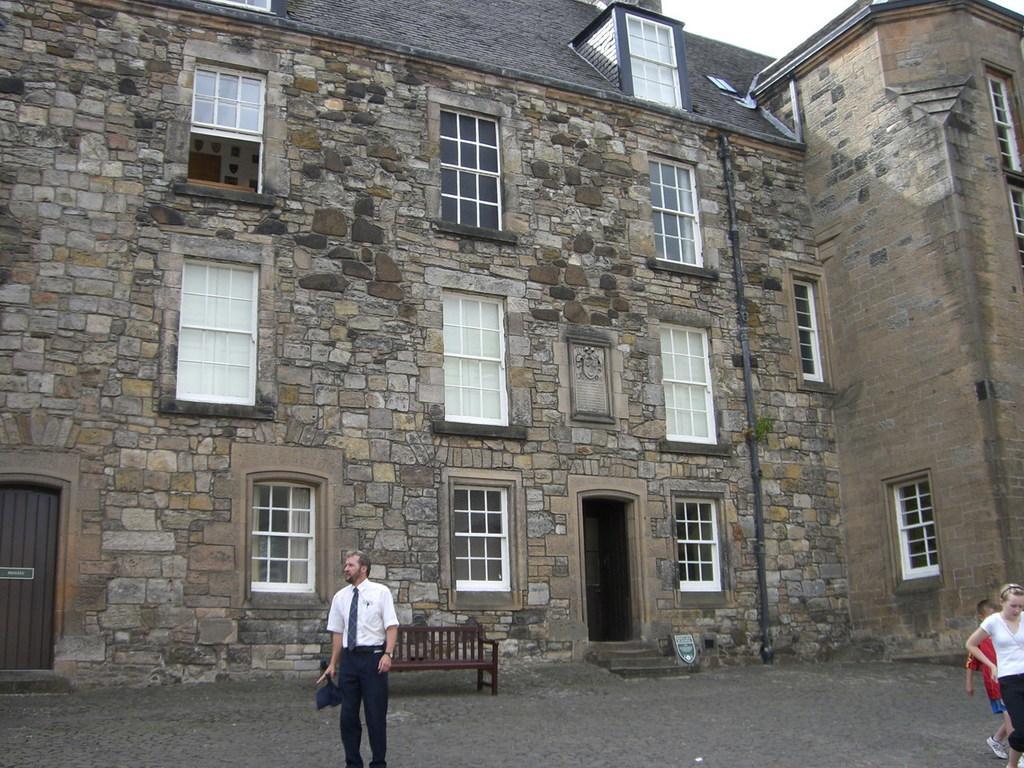Describe this image in one or two sentences. In the image I can see a building to which there are some windows and a door and also I can see some people and a bench in front of the building. 